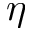<formula> <loc_0><loc_0><loc_500><loc_500>\eta</formula> 